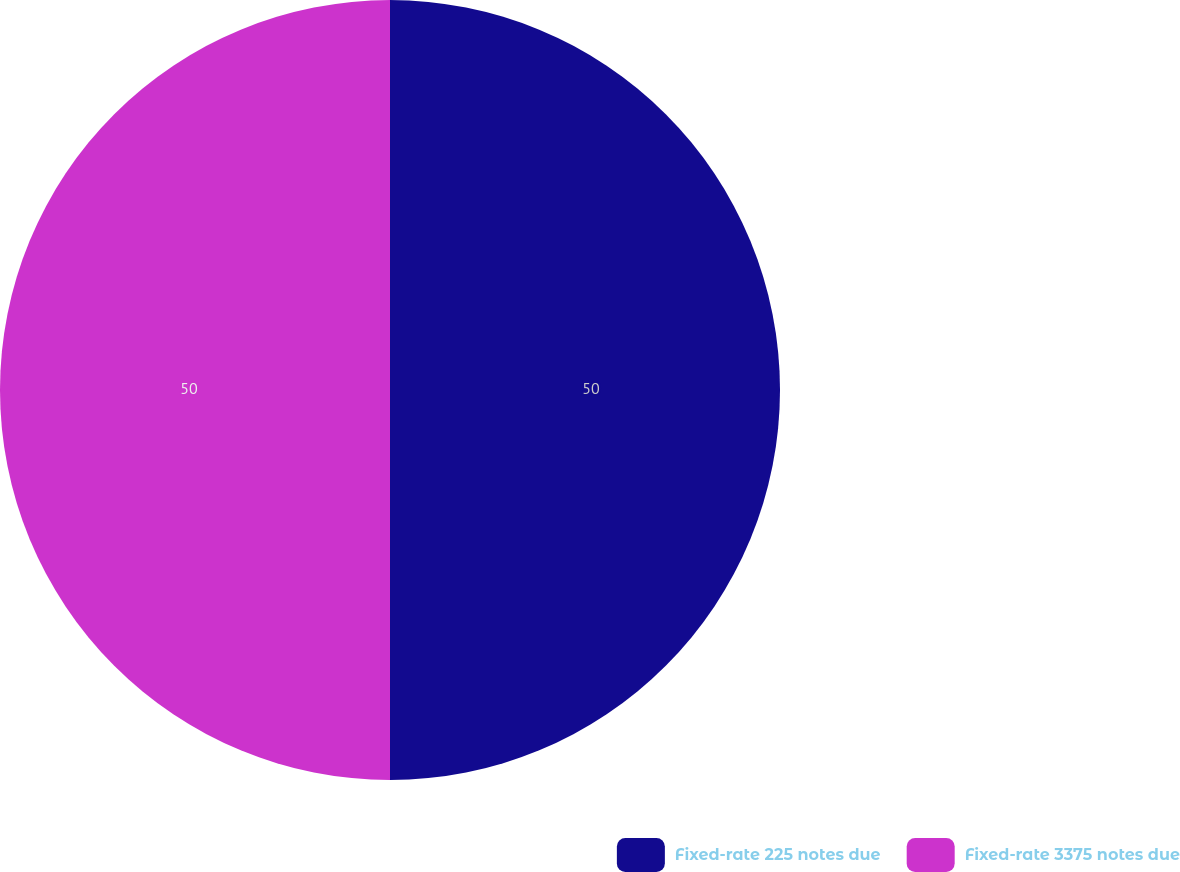Convert chart to OTSL. <chart><loc_0><loc_0><loc_500><loc_500><pie_chart><fcel>Fixed-rate 225 notes due<fcel>Fixed-rate 3375 notes due<nl><fcel>50.0%<fcel>50.0%<nl></chart> 